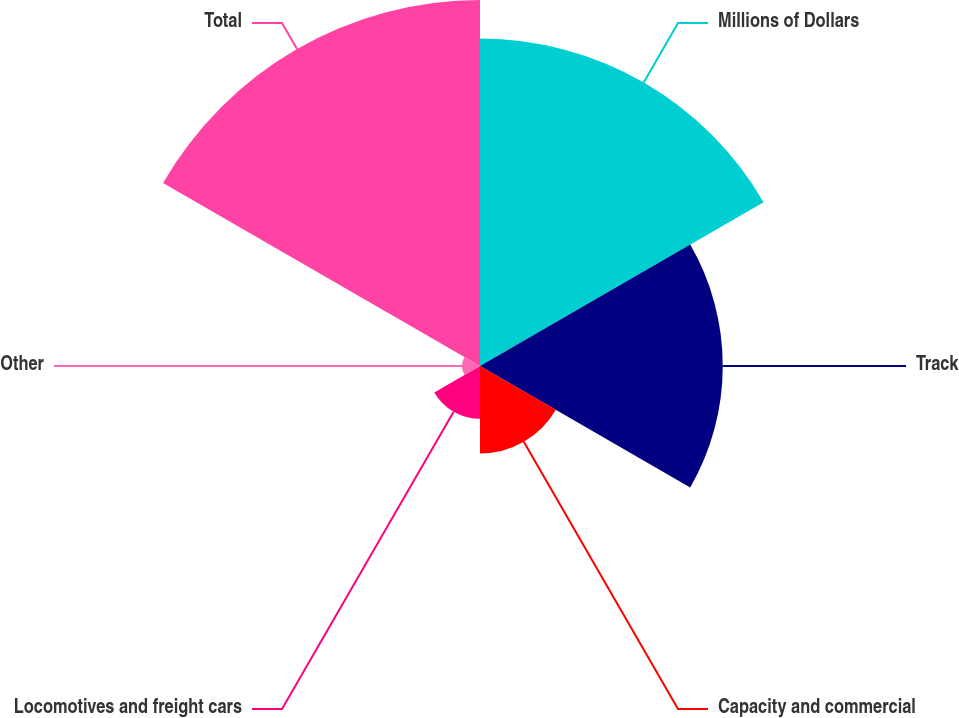Convert chart to OTSL. <chart><loc_0><loc_0><loc_500><loc_500><pie_chart><fcel>Millions of Dollars<fcel>Track<fcel>Capacity and commercial<fcel>Locomotives and freight cars<fcel>Other<fcel>Total<nl><fcel>29.92%<fcel>22.18%<fcel>8.0%<fcel>4.82%<fcel>1.64%<fcel>33.44%<nl></chart> 